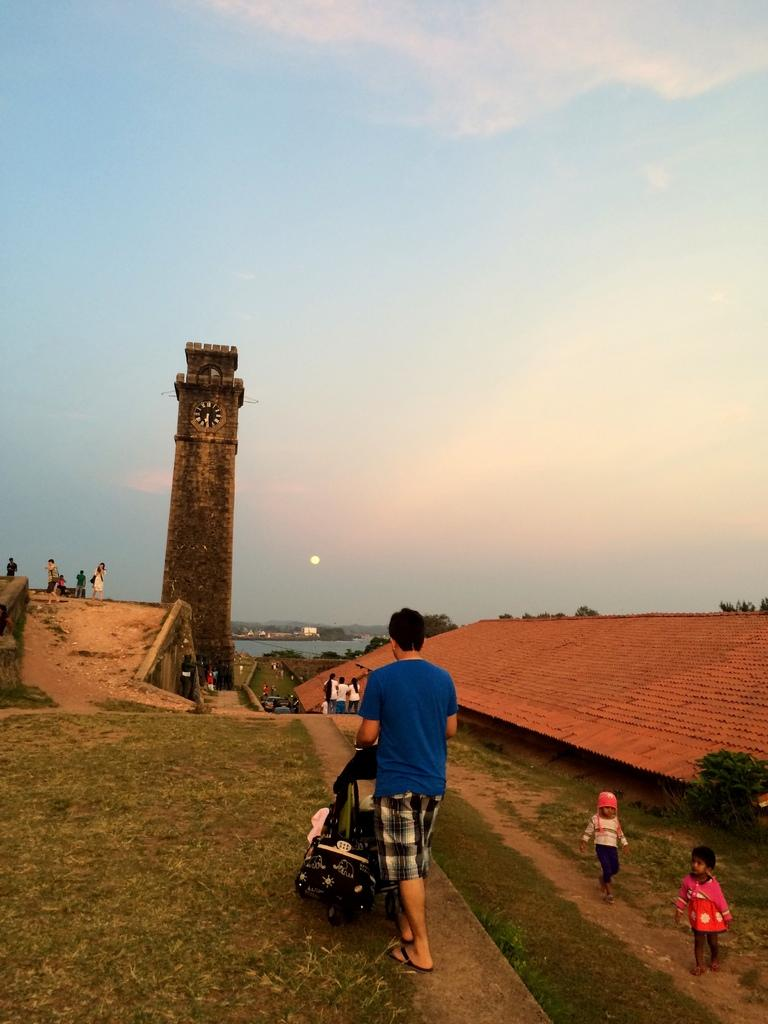What can be seen in the image? There are persons standing in the image. What is located in front of the persons? There is a clock tower in front of the persons. What type of natural elements can be seen in the background of the image? There are trees and water visible in the background of the image. What type of muscle is visible on the uncle's arm in the image? There is no uncle present in the image, and therefore no muscle can be observed on an uncle's arm. What type of skirt is the person wearing in the image? The provided facts do not mention any person wearing a skirt in the image. 